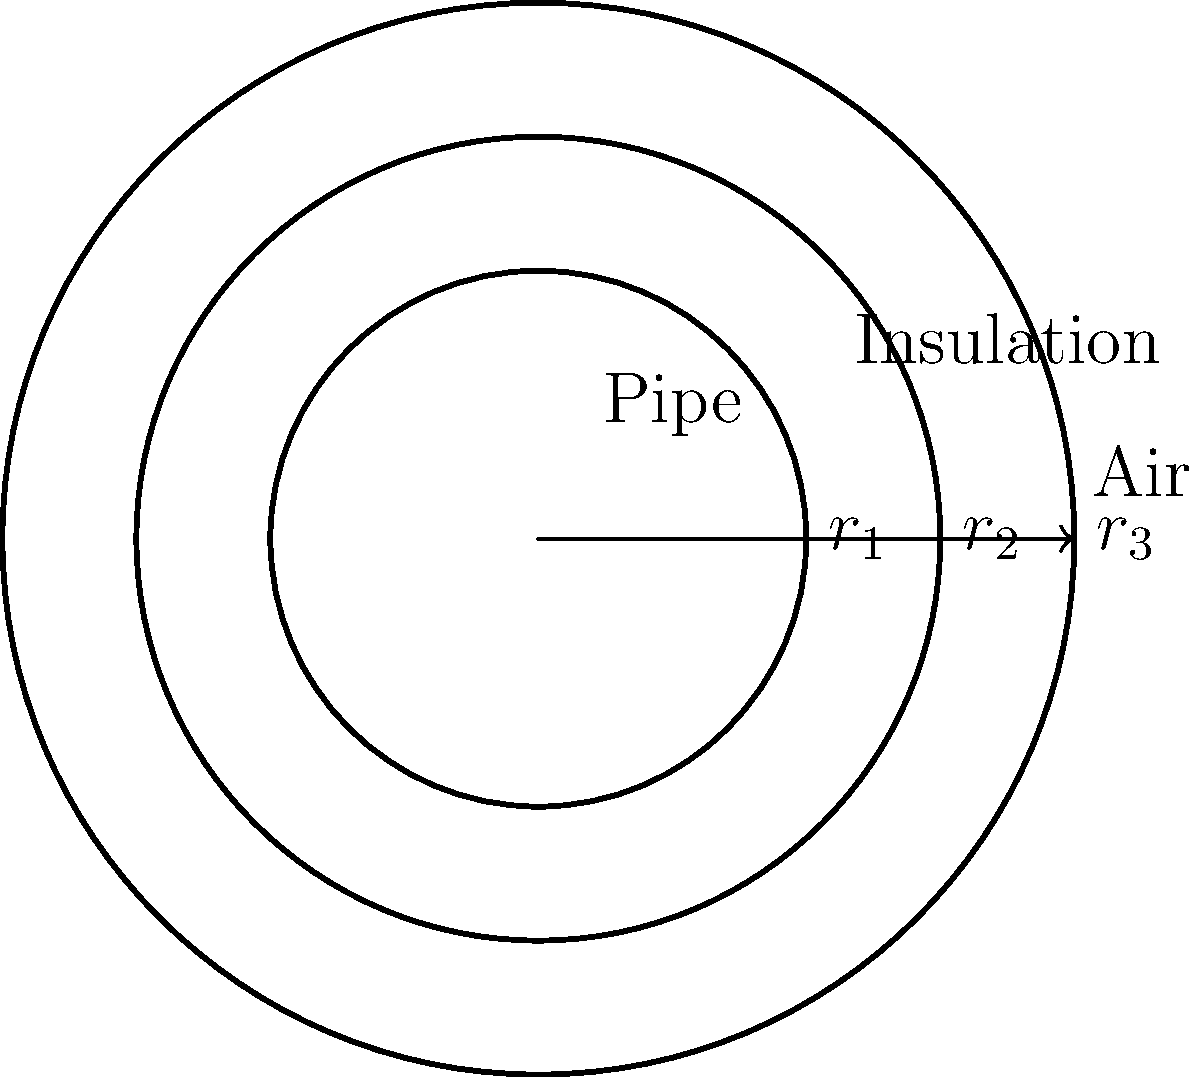In our days working together at the lab, we often discussed heat transfer problems. Consider a cylindrical pipe with inner radius $r_1 = 5$ cm, outer radius $r_2 = 6$ cm, and insulation thickness of 2 cm. The thermal conductivity of the pipe material is $k_p = 50$ W/(m·K), and that of the insulation is $k_i = 0.05$ W/(m·K). If the inner surface temperature is $T_1 = 100°C$ and the outer surface temperature is $T_3 = 30°C$, what is the rate of heat transfer per unit length of the pipe? Let's approach this step-by-step, just like we used to in our lab discussions:

1) First, recall the equation for heat transfer through a cylindrical wall:

   $$Q = \frac{2\pi k L (T_1 - T_2)}{\ln(r_2/r_1)}$$

   where $Q$ is the heat transfer rate, $k$ is the thermal conductivity, $L$ is the length, and $T_1$ and $T_2$ are the inner and outer temperatures respectively.

2) We have two layers (pipe and insulation), so we'll use the concept of thermal resistance in series:

   $$R_{total} = R_{pipe} + R_{insulation}$$

3) The thermal resistance for a cylindrical layer is given by:

   $$R = \frac{\ln(r_{outer}/r_{inner})}{2\pi k L}$$

4) For the pipe:
   $$R_p = \frac{\ln(0.06/0.05)}{2\pi \cdot 50 \cdot 1} = 1.91 \times 10^{-4}$$ K/W per meter

5) For the insulation:
   $$R_i = \frac{\ln(0.08/0.06)}{2\pi \cdot 0.05 \cdot 1} = 1.85$$ K/W per meter

6) Total resistance:
   $$R_{total} = 1.91 \times 10^{-4} + 1.85 = 1.85$$ K/W per meter

7) Now we can use the overall temperature difference and total resistance:

   $$Q/L = \frac{T_1 - T_3}{R_{total}} = \frac{100 - 30}{1.85} = 37.84$$ W/m

Therefore, the rate of heat transfer per unit length of the pipe is approximately 37.84 W/m.
Answer: 37.84 W/m 